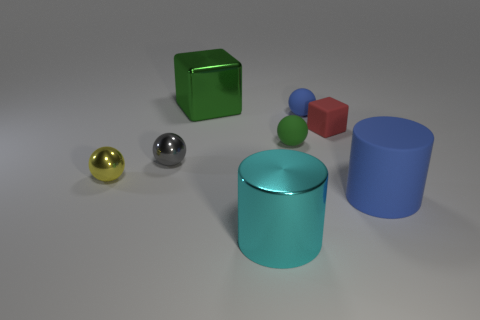Add 1 big blue rubber cylinders. How many objects exist? 9 Subtract all cubes. How many objects are left? 6 Subtract all large yellow metallic things. Subtract all yellow balls. How many objects are left? 7 Add 5 big metal cubes. How many big metal cubes are left? 6 Add 6 small yellow balls. How many small yellow balls exist? 7 Subtract 0 purple spheres. How many objects are left? 8 